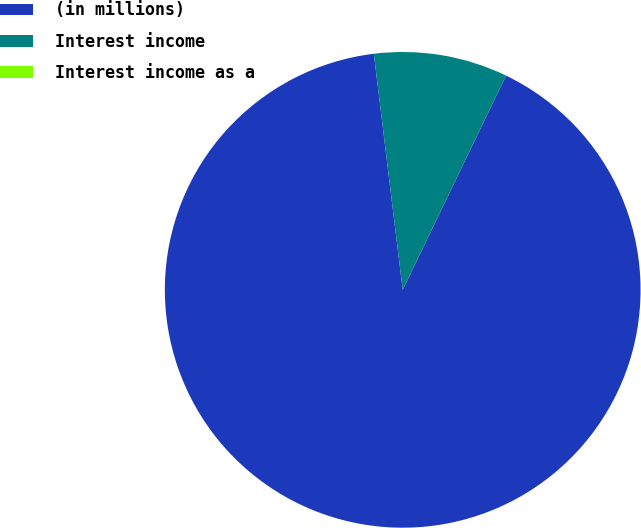Convert chart. <chart><loc_0><loc_0><loc_500><loc_500><pie_chart><fcel>(in millions)<fcel>Interest income<fcel>Interest income as a<nl><fcel>90.9%<fcel>9.09%<fcel>0.0%<nl></chart> 